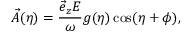Convert formula to latex. <formula><loc_0><loc_0><loc_500><loc_500>\vec { A } ( \eta ) = \frac { \vec { e } _ { z } E } { \omega } g ( \eta ) \cos ( \eta + \phi ) ,</formula> 